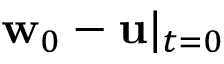Convert formula to latex. <formula><loc_0><loc_0><loc_500><loc_500>w _ { 0 } - u | _ { t = 0 }</formula> 